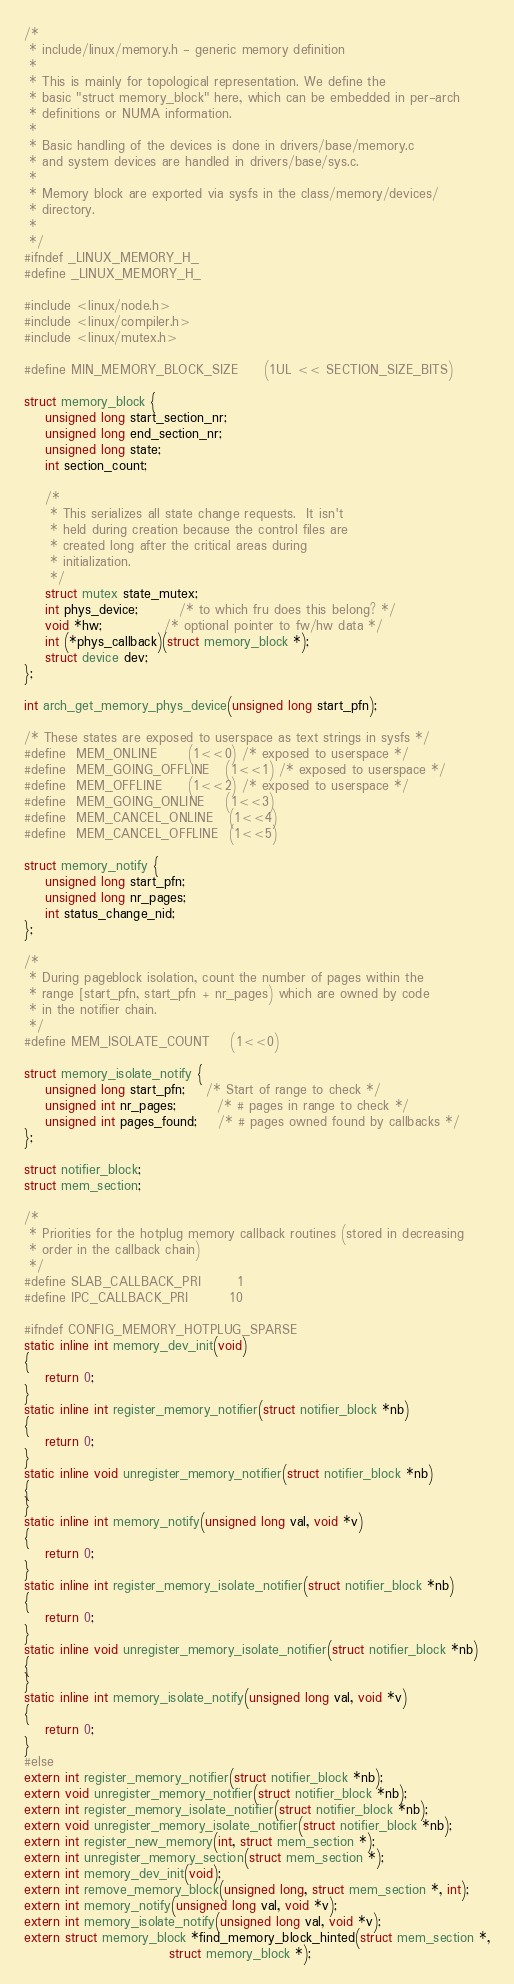Convert code to text. <code><loc_0><loc_0><loc_500><loc_500><_C_>/*
 * include/linux/memory.h - generic memory definition
 *
 * This is mainly for topological representation. We define the
 * basic "struct memory_block" here, which can be embedded in per-arch
 * definitions or NUMA information.
 *
 * Basic handling of the devices is done in drivers/base/memory.c
 * and system devices are handled in drivers/base/sys.c.
 *
 * Memory block are exported via sysfs in the class/memory/devices/
 * directory.
 *
 */
#ifndef _LINUX_MEMORY_H_
#define _LINUX_MEMORY_H_

#include <linux/node.h>
#include <linux/compiler.h>
#include <linux/mutex.h>

#define MIN_MEMORY_BLOCK_SIZE     (1UL << SECTION_SIZE_BITS)

struct memory_block {
	unsigned long start_section_nr;
	unsigned long end_section_nr;
	unsigned long state;
	int section_count;

	/*
	 * This serializes all state change requests.  It isn't
	 * held during creation because the control files are
	 * created long after the critical areas during
	 * initialization.
	 */
	struct mutex state_mutex;
	int phys_device;		/* to which fru does this belong? */
	void *hw;			/* optional pointer to fw/hw data */
	int (*phys_callback)(struct memory_block *);
	struct device dev;
};

int arch_get_memory_phys_device(unsigned long start_pfn);

/* These states are exposed to userspace as text strings in sysfs */
#define	MEM_ONLINE		(1<<0) /* exposed to userspace */
#define	MEM_GOING_OFFLINE	(1<<1) /* exposed to userspace */
#define	MEM_OFFLINE		(1<<2) /* exposed to userspace */
#define	MEM_GOING_ONLINE	(1<<3)
#define	MEM_CANCEL_ONLINE	(1<<4)
#define	MEM_CANCEL_OFFLINE	(1<<5)

struct memory_notify {
	unsigned long start_pfn;
	unsigned long nr_pages;
	int status_change_nid;
};

/*
 * During pageblock isolation, count the number of pages within the
 * range [start_pfn, start_pfn + nr_pages) which are owned by code
 * in the notifier chain.
 */
#define MEM_ISOLATE_COUNT	(1<<0)

struct memory_isolate_notify {
	unsigned long start_pfn;	/* Start of range to check */
	unsigned int nr_pages;		/* # pages in range to check */
	unsigned int pages_found;	/* # pages owned found by callbacks */
};

struct notifier_block;
struct mem_section;

/*
 * Priorities for the hotplug memory callback routines (stored in decreasing
 * order in the callback chain)
 */
#define SLAB_CALLBACK_PRI       1
#define IPC_CALLBACK_PRI        10

#ifndef CONFIG_MEMORY_HOTPLUG_SPARSE
static inline int memory_dev_init(void)
{
	return 0;
}
static inline int register_memory_notifier(struct notifier_block *nb)
{
	return 0;
}
static inline void unregister_memory_notifier(struct notifier_block *nb)
{
}
static inline int memory_notify(unsigned long val, void *v)
{
	return 0;
}
static inline int register_memory_isolate_notifier(struct notifier_block *nb)
{
	return 0;
}
static inline void unregister_memory_isolate_notifier(struct notifier_block *nb)
{
}
static inline int memory_isolate_notify(unsigned long val, void *v)
{
	return 0;
}
#else
extern int register_memory_notifier(struct notifier_block *nb);
extern void unregister_memory_notifier(struct notifier_block *nb);
extern int register_memory_isolate_notifier(struct notifier_block *nb);
extern void unregister_memory_isolate_notifier(struct notifier_block *nb);
extern int register_new_memory(int, struct mem_section *);
extern int unregister_memory_section(struct mem_section *);
extern int memory_dev_init(void);
extern int remove_memory_block(unsigned long, struct mem_section *, int);
extern int memory_notify(unsigned long val, void *v);
extern int memory_isolate_notify(unsigned long val, void *v);
extern struct memory_block *find_memory_block_hinted(struct mem_section *,
							struct memory_block *);</code> 